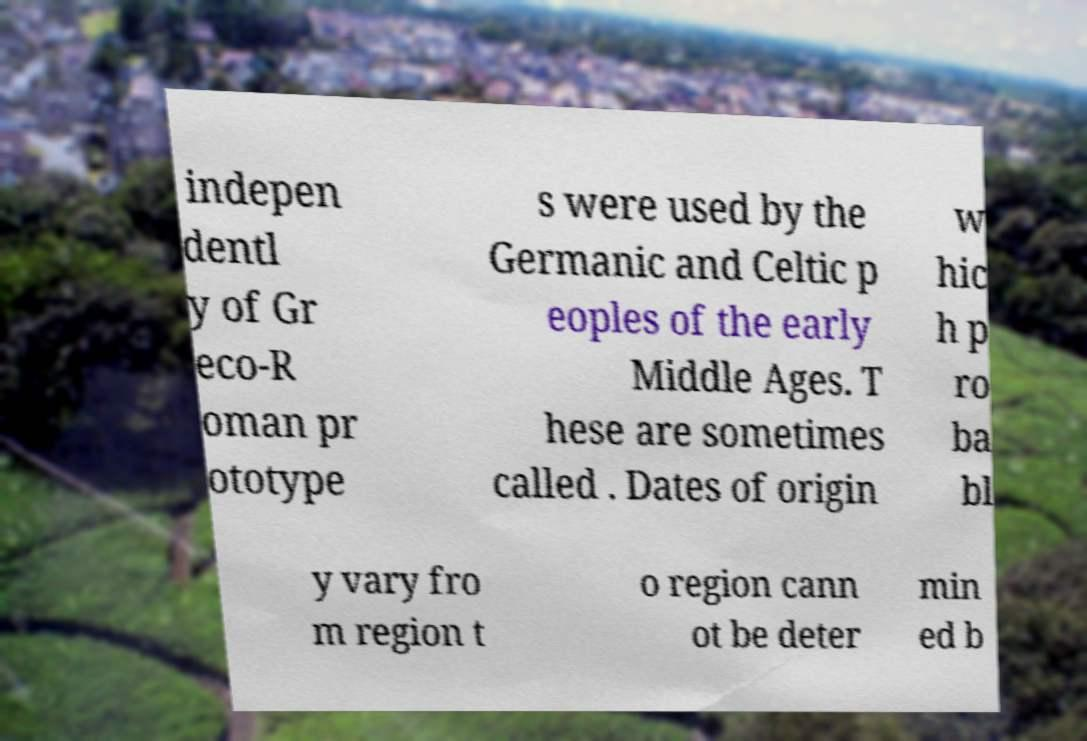There's text embedded in this image that I need extracted. Can you transcribe it verbatim? indepen dentl y of Gr eco-R oman pr ototype s were used by the Germanic and Celtic p eoples of the early Middle Ages. T hese are sometimes called . Dates of origin w hic h p ro ba bl y vary fro m region t o region cann ot be deter min ed b 